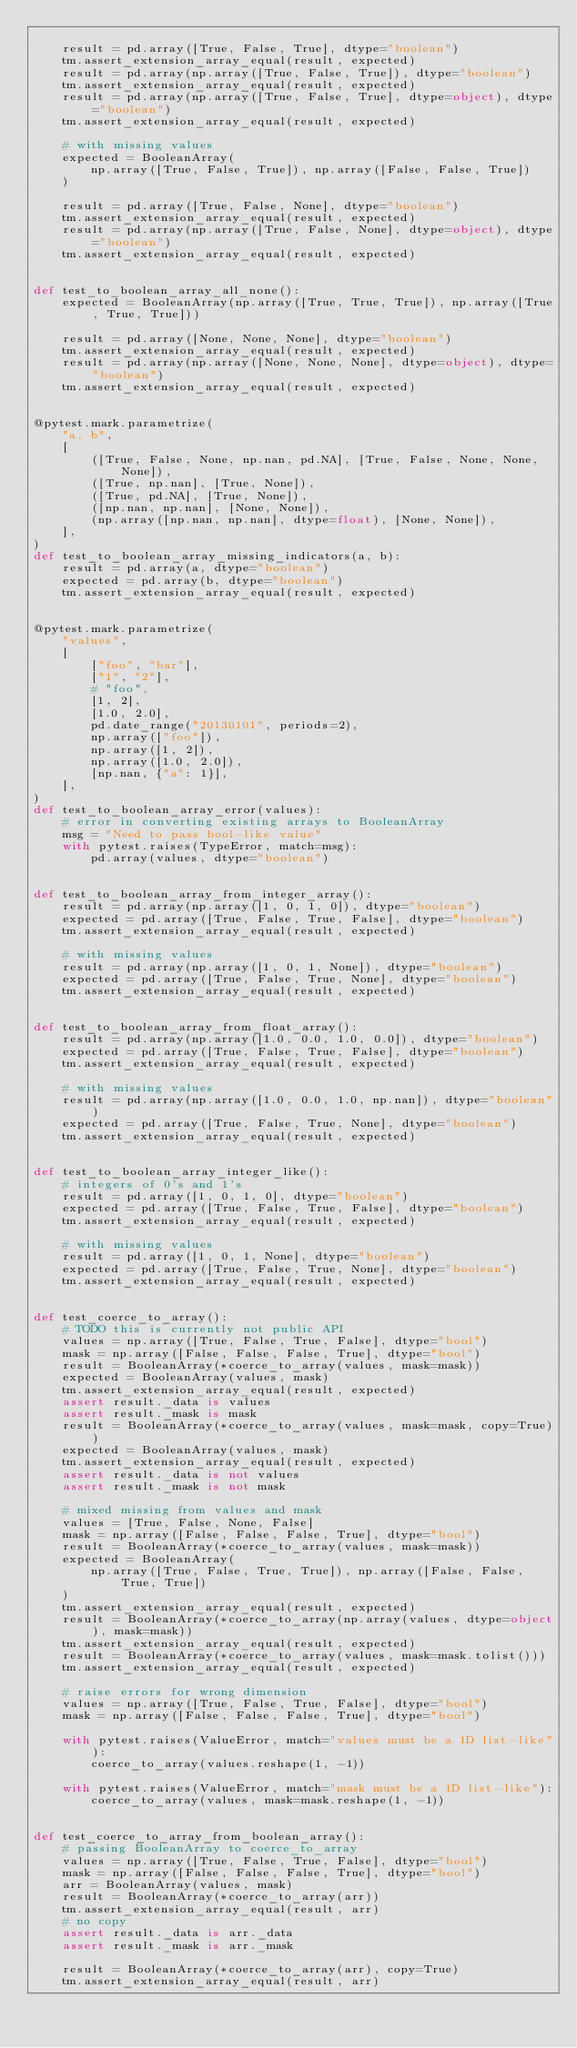<code> <loc_0><loc_0><loc_500><loc_500><_Python_>
    result = pd.array([True, False, True], dtype="boolean")
    tm.assert_extension_array_equal(result, expected)
    result = pd.array(np.array([True, False, True]), dtype="boolean")
    tm.assert_extension_array_equal(result, expected)
    result = pd.array(np.array([True, False, True], dtype=object), dtype="boolean")
    tm.assert_extension_array_equal(result, expected)

    # with missing values
    expected = BooleanArray(
        np.array([True, False, True]), np.array([False, False, True])
    )

    result = pd.array([True, False, None], dtype="boolean")
    tm.assert_extension_array_equal(result, expected)
    result = pd.array(np.array([True, False, None], dtype=object), dtype="boolean")
    tm.assert_extension_array_equal(result, expected)


def test_to_boolean_array_all_none():
    expected = BooleanArray(np.array([True, True, True]), np.array([True, True, True]))

    result = pd.array([None, None, None], dtype="boolean")
    tm.assert_extension_array_equal(result, expected)
    result = pd.array(np.array([None, None, None], dtype=object), dtype="boolean")
    tm.assert_extension_array_equal(result, expected)


@pytest.mark.parametrize(
    "a, b",
    [
        ([True, False, None, np.nan, pd.NA], [True, False, None, None, None]),
        ([True, np.nan], [True, None]),
        ([True, pd.NA], [True, None]),
        ([np.nan, np.nan], [None, None]),
        (np.array([np.nan, np.nan], dtype=float), [None, None]),
    ],
)
def test_to_boolean_array_missing_indicators(a, b):
    result = pd.array(a, dtype="boolean")
    expected = pd.array(b, dtype="boolean")
    tm.assert_extension_array_equal(result, expected)


@pytest.mark.parametrize(
    "values",
    [
        ["foo", "bar"],
        ["1", "2"],
        # "foo",
        [1, 2],
        [1.0, 2.0],
        pd.date_range("20130101", periods=2),
        np.array(["foo"]),
        np.array([1, 2]),
        np.array([1.0, 2.0]),
        [np.nan, {"a": 1}],
    ],
)
def test_to_boolean_array_error(values):
    # error in converting existing arrays to BooleanArray
    msg = "Need to pass bool-like value"
    with pytest.raises(TypeError, match=msg):
        pd.array(values, dtype="boolean")


def test_to_boolean_array_from_integer_array():
    result = pd.array(np.array([1, 0, 1, 0]), dtype="boolean")
    expected = pd.array([True, False, True, False], dtype="boolean")
    tm.assert_extension_array_equal(result, expected)

    # with missing values
    result = pd.array(np.array([1, 0, 1, None]), dtype="boolean")
    expected = pd.array([True, False, True, None], dtype="boolean")
    tm.assert_extension_array_equal(result, expected)


def test_to_boolean_array_from_float_array():
    result = pd.array(np.array([1.0, 0.0, 1.0, 0.0]), dtype="boolean")
    expected = pd.array([True, False, True, False], dtype="boolean")
    tm.assert_extension_array_equal(result, expected)

    # with missing values
    result = pd.array(np.array([1.0, 0.0, 1.0, np.nan]), dtype="boolean")
    expected = pd.array([True, False, True, None], dtype="boolean")
    tm.assert_extension_array_equal(result, expected)


def test_to_boolean_array_integer_like():
    # integers of 0's and 1's
    result = pd.array([1, 0, 1, 0], dtype="boolean")
    expected = pd.array([True, False, True, False], dtype="boolean")
    tm.assert_extension_array_equal(result, expected)

    # with missing values
    result = pd.array([1, 0, 1, None], dtype="boolean")
    expected = pd.array([True, False, True, None], dtype="boolean")
    tm.assert_extension_array_equal(result, expected)


def test_coerce_to_array():
    # TODO this is currently not public API
    values = np.array([True, False, True, False], dtype="bool")
    mask = np.array([False, False, False, True], dtype="bool")
    result = BooleanArray(*coerce_to_array(values, mask=mask))
    expected = BooleanArray(values, mask)
    tm.assert_extension_array_equal(result, expected)
    assert result._data is values
    assert result._mask is mask
    result = BooleanArray(*coerce_to_array(values, mask=mask, copy=True))
    expected = BooleanArray(values, mask)
    tm.assert_extension_array_equal(result, expected)
    assert result._data is not values
    assert result._mask is not mask

    # mixed missing from values and mask
    values = [True, False, None, False]
    mask = np.array([False, False, False, True], dtype="bool")
    result = BooleanArray(*coerce_to_array(values, mask=mask))
    expected = BooleanArray(
        np.array([True, False, True, True]), np.array([False, False, True, True])
    )
    tm.assert_extension_array_equal(result, expected)
    result = BooleanArray(*coerce_to_array(np.array(values, dtype=object), mask=mask))
    tm.assert_extension_array_equal(result, expected)
    result = BooleanArray(*coerce_to_array(values, mask=mask.tolist()))
    tm.assert_extension_array_equal(result, expected)

    # raise errors for wrong dimension
    values = np.array([True, False, True, False], dtype="bool")
    mask = np.array([False, False, False, True], dtype="bool")

    with pytest.raises(ValueError, match="values must be a 1D list-like"):
        coerce_to_array(values.reshape(1, -1))

    with pytest.raises(ValueError, match="mask must be a 1D list-like"):
        coerce_to_array(values, mask=mask.reshape(1, -1))


def test_coerce_to_array_from_boolean_array():
    # passing BooleanArray to coerce_to_array
    values = np.array([True, False, True, False], dtype="bool")
    mask = np.array([False, False, False, True], dtype="bool")
    arr = BooleanArray(values, mask)
    result = BooleanArray(*coerce_to_array(arr))
    tm.assert_extension_array_equal(result, arr)
    # no copy
    assert result._data is arr._data
    assert result._mask is arr._mask

    result = BooleanArray(*coerce_to_array(arr), copy=True)
    tm.assert_extension_array_equal(result, arr)</code> 